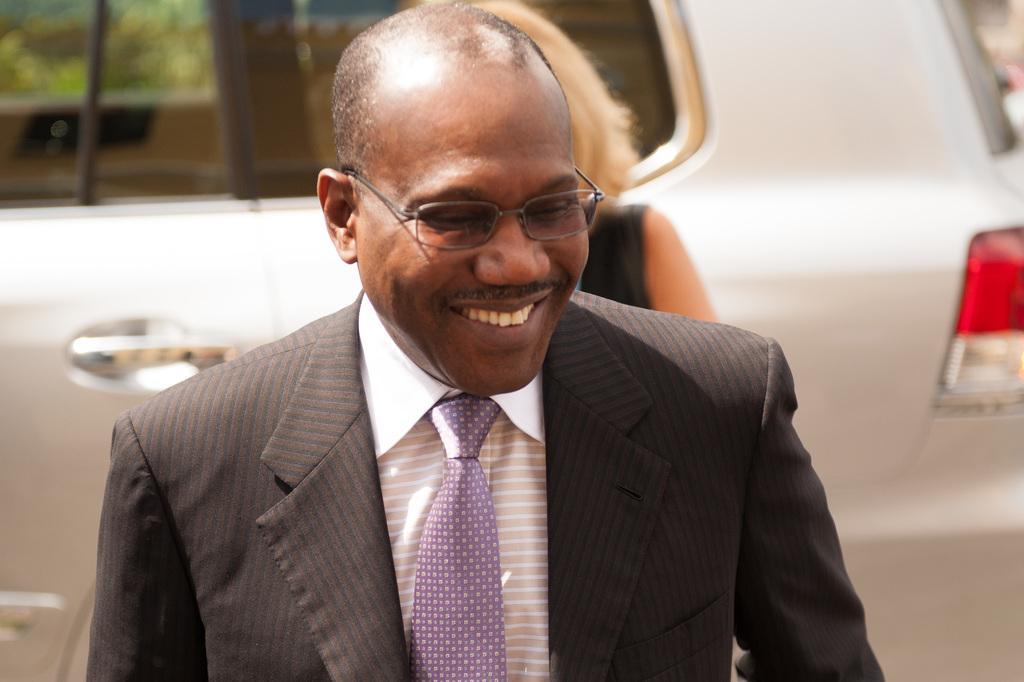Describe this image in one or two sentences. In this image I see a man who is wearing suit and I see that he is smiling. In the background I see another person and I see a white car over here. 